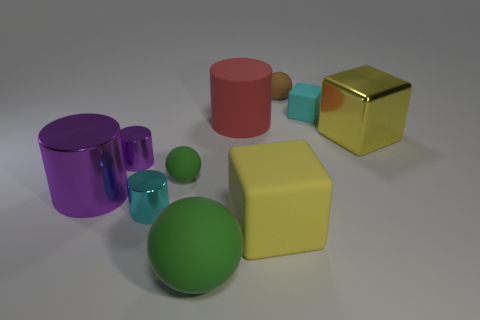Which object appears to be the most reflective, and why might that be? The gold cube appears to be the most reflective object, exhibiting a shiny surface that mirrors its surroundings. This increased reflectivity suggests it has a polished, possibly metallic surface, which contrasts with the matte textures of the other objects. 